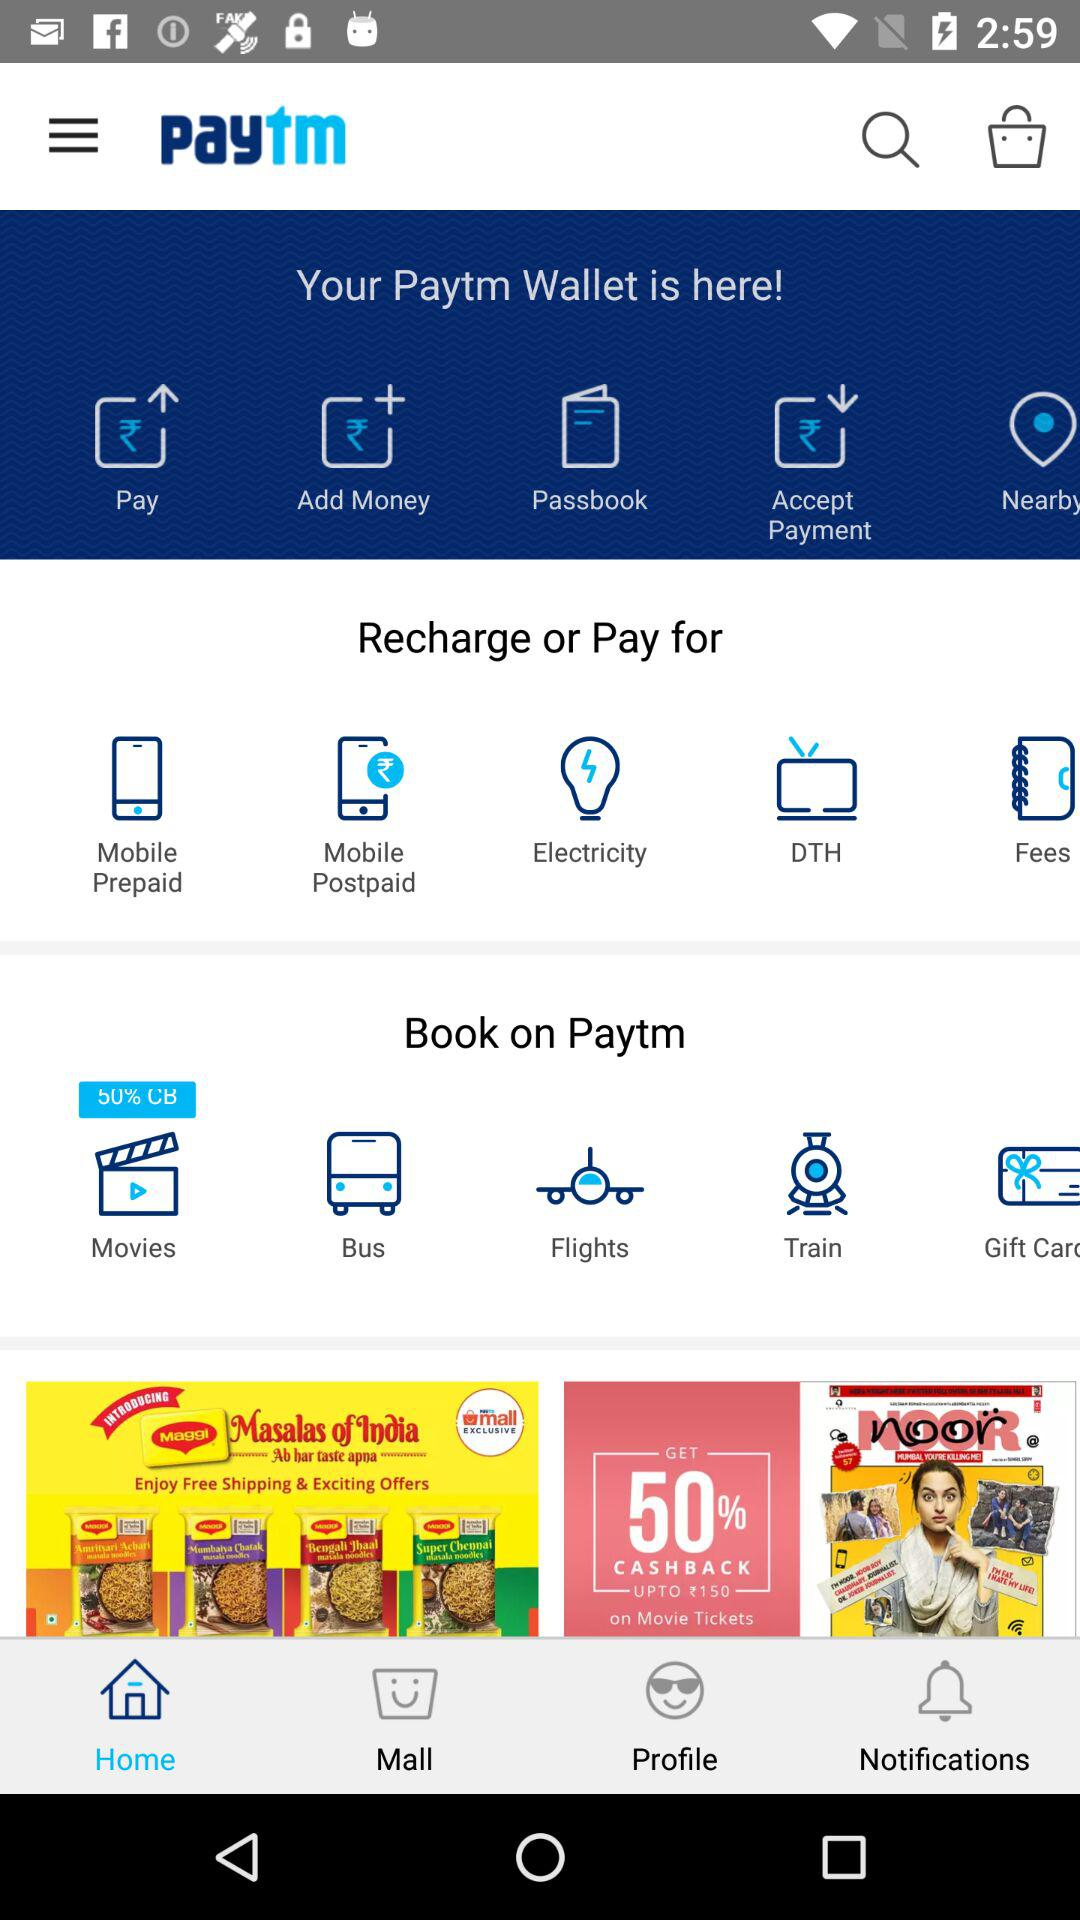Which option has been selected? The option that has been selected is "Home". 